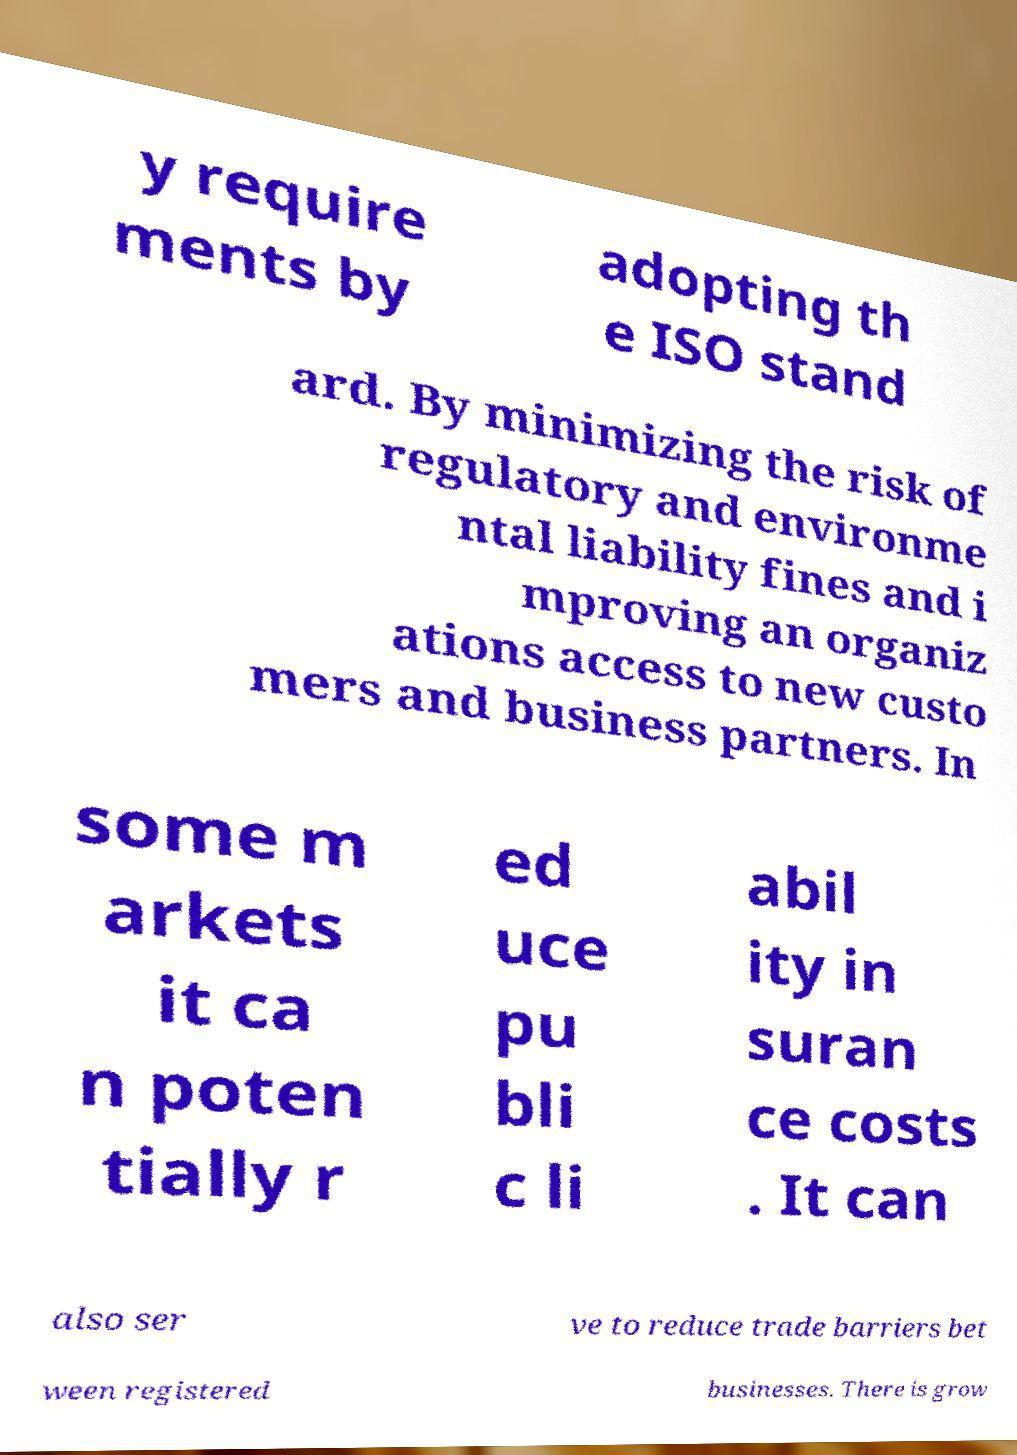There's text embedded in this image that I need extracted. Can you transcribe it verbatim? y require ments by adopting th e ISO stand ard. By minimizing the risk of regulatory and environme ntal liability fines and i mproving an organiz ations access to new custo mers and business partners. In some m arkets it ca n poten tially r ed uce pu bli c li abil ity in suran ce costs . It can also ser ve to reduce trade barriers bet ween registered businesses. There is grow 